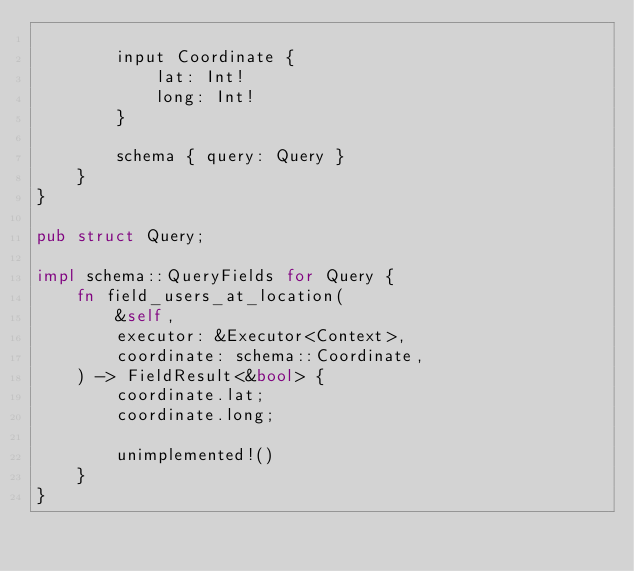Convert code to text. <code><loc_0><loc_0><loc_500><loc_500><_Rust_>
        input Coordinate {
            lat: Int!
            long: Int!
        }

        schema { query: Query }
    }
}

pub struct Query;

impl schema::QueryFields for Query {
    fn field_users_at_location(
        &self,
        executor: &Executor<Context>,
        coordinate: schema::Coordinate,
    ) -> FieldResult<&bool> {
        coordinate.lat;
        coordinate.long;

        unimplemented!()
    }
}
</code> 